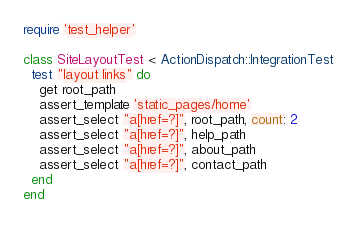Convert code to text. <code><loc_0><loc_0><loc_500><loc_500><_Ruby_>require 'test_helper'

class SiteLayoutTest < ActionDispatch::IntegrationTest
  test "layout links" do
    get root_path
    assert_template 'static_pages/home'
    assert_select "a[href=?]", root_path, count: 2
    assert_select "a[href=?]", help_path
    assert_select "a[href=?]", about_path
    assert_select "a[href=?]", contact_path   
  end
end
</code> 